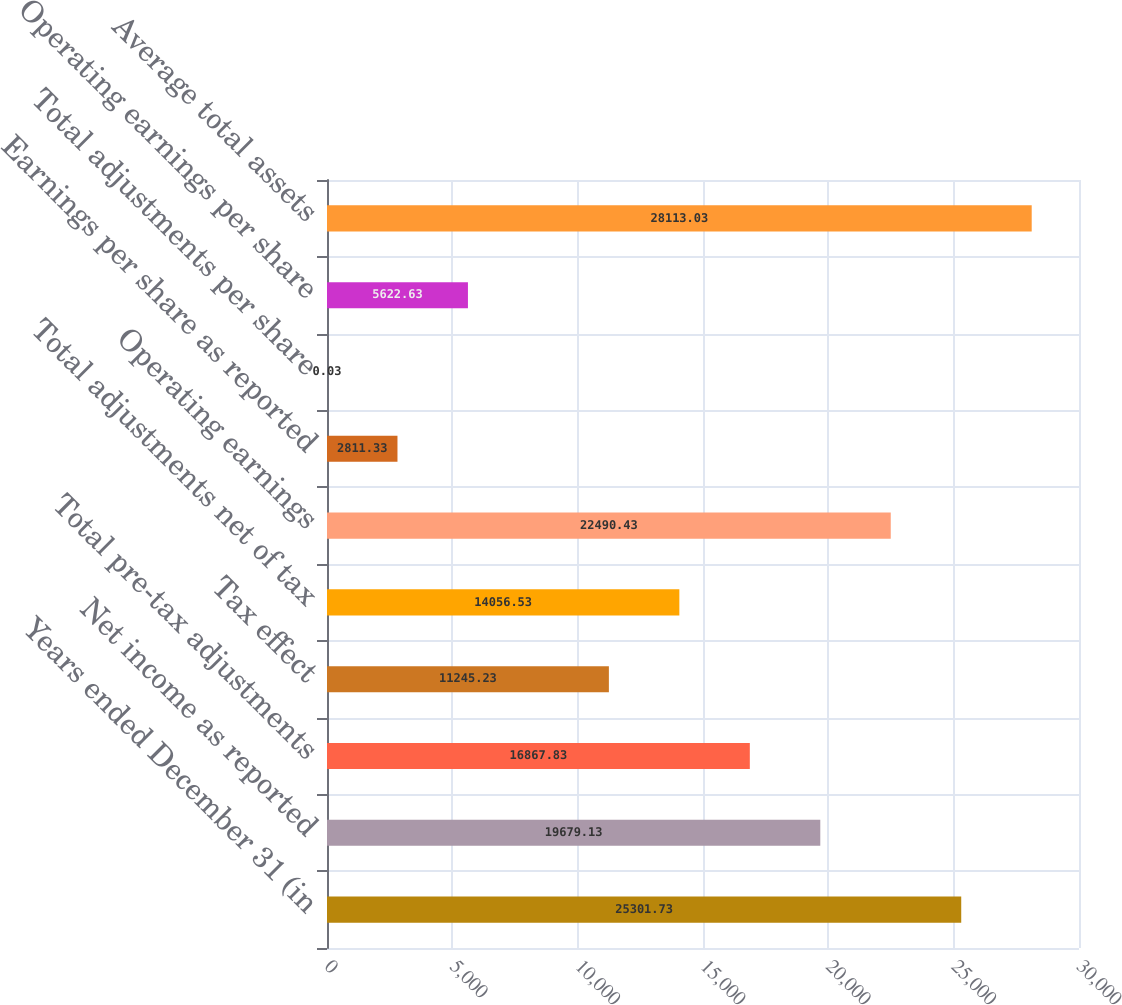<chart> <loc_0><loc_0><loc_500><loc_500><bar_chart><fcel>Years ended December 31 (in<fcel>Net income as reported<fcel>Total pre-tax adjustments<fcel>Tax effect<fcel>Total adjustments net of tax<fcel>Operating earnings<fcel>Earnings per share as reported<fcel>Total adjustments per share<fcel>Operating earnings per share<fcel>Average total assets<nl><fcel>25301.7<fcel>19679.1<fcel>16867.8<fcel>11245.2<fcel>14056.5<fcel>22490.4<fcel>2811.33<fcel>0.03<fcel>5622.63<fcel>28113<nl></chart> 